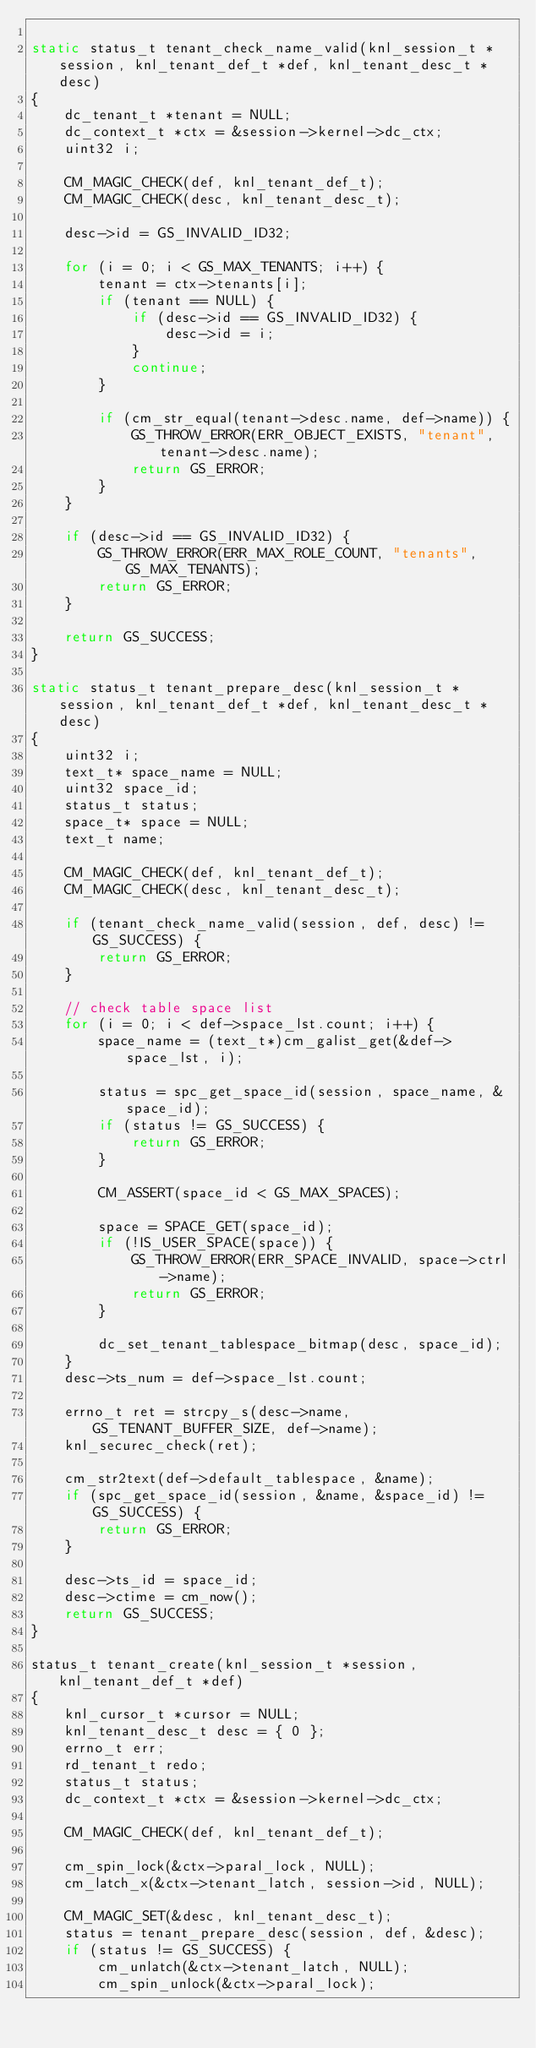Convert code to text. <code><loc_0><loc_0><loc_500><loc_500><_C_>
static status_t tenant_check_name_valid(knl_session_t *session, knl_tenant_def_t *def, knl_tenant_desc_t *desc)
{
    dc_tenant_t *tenant = NULL;
    dc_context_t *ctx = &session->kernel->dc_ctx;
    uint32 i;

    CM_MAGIC_CHECK(def, knl_tenant_def_t);
    CM_MAGIC_CHECK(desc, knl_tenant_desc_t);

    desc->id = GS_INVALID_ID32;

    for (i = 0; i < GS_MAX_TENANTS; i++) {
        tenant = ctx->tenants[i];
        if (tenant == NULL) {
            if (desc->id == GS_INVALID_ID32) {
                desc->id = i;
            }
            continue;
        }

        if (cm_str_equal(tenant->desc.name, def->name)) {
            GS_THROW_ERROR(ERR_OBJECT_EXISTS, "tenant", tenant->desc.name);
            return GS_ERROR;
        }
    }

    if (desc->id == GS_INVALID_ID32) {
        GS_THROW_ERROR(ERR_MAX_ROLE_COUNT, "tenants", GS_MAX_TENANTS);
        return GS_ERROR;
    }

    return GS_SUCCESS;
}

static status_t tenant_prepare_desc(knl_session_t *session, knl_tenant_def_t *def, knl_tenant_desc_t *desc)
{
    uint32 i;
    text_t* space_name = NULL;
    uint32 space_id;
    status_t status;
    space_t* space = NULL;
    text_t name;

    CM_MAGIC_CHECK(def, knl_tenant_def_t);
    CM_MAGIC_CHECK(desc, knl_tenant_desc_t);

    if (tenant_check_name_valid(session, def, desc) != GS_SUCCESS) {
        return GS_ERROR;
    }

    // check table space list
    for (i = 0; i < def->space_lst.count; i++) {
        space_name = (text_t*)cm_galist_get(&def->space_lst, i);

        status = spc_get_space_id(session, space_name, &space_id);
        if (status != GS_SUCCESS) {
            return GS_ERROR;
        }

        CM_ASSERT(space_id < GS_MAX_SPACES);

        space = SPACE_GET(space_id);
        if (!IS_USER_SPACE(space)) {
            GS_THROW_ERROR(ERR_SPACE_INVALID, space->ctrl->name);
            return GS_ERROR;
        }

        dc_set_tenant_tablespace_bitmap(desc, space_id);
    }
    desc->ts_num = def->space_lst.count;

    errno_t ret = strcpy_s(desc->name, GS_TENANT_BUFFER_SIZE, def->name);
    knl_securec_check(ret);

    cm_str2text(def->default_tablespace, &name);
    if (spc_get_space_id(session, &name, &space_id) != GS_SUCCESS) {
        return GS_ERROR;
    }

    desc->ts_id = space_id;
    desc->ctime = cm_now();
    return GS_SUCCESS;
}

status_t tenant_create(knl_session_t *session, knl_tenant_def_t *def)
{
    knl_cursor_t *cursor = NULL;
    knl_tenant_desc_t desc = { 0 };
    errno_t err;
    rd_tenant_t redo;
    status_t status;
    dc_context_t *ctx = &session->kernel->dc_ctx;

    CM_MAGIC_CHECK(def, knl_tenant_def_t);

    cm_spin_lock(&ctx->paral_lock, NULL);
    cm_latch_x(&ctx->tenant_latch, session->id, NULL);

    CM_MAGIC_SET(&desc, knl_tenant_desc_t);
    status = tenant_prepare_desc(session, def, &desc);
    if (status != GS_SUCCESS) {
        cm_unlatch(&ctx->tenant_latch, NULL);
        cm_spin_unlock(&ctx->paral_lock);</code> 